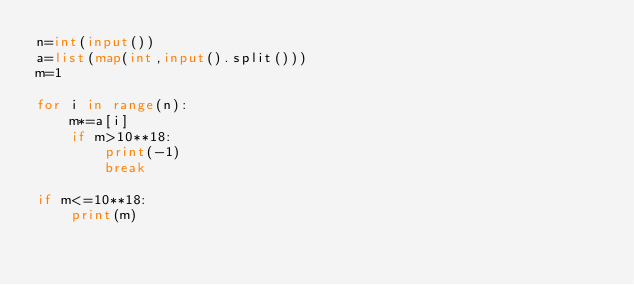Convert code to text. <code><loc_0><loc_0><loc_500><loc_500><_Python_>n=int(input())
a=list(map(int,input().split()))
m=1

for i in range(n):
    m*=a[i]
    if m>10**18:
        print(-1)
        break

if m<=10**18:
    print(m)
</code> 